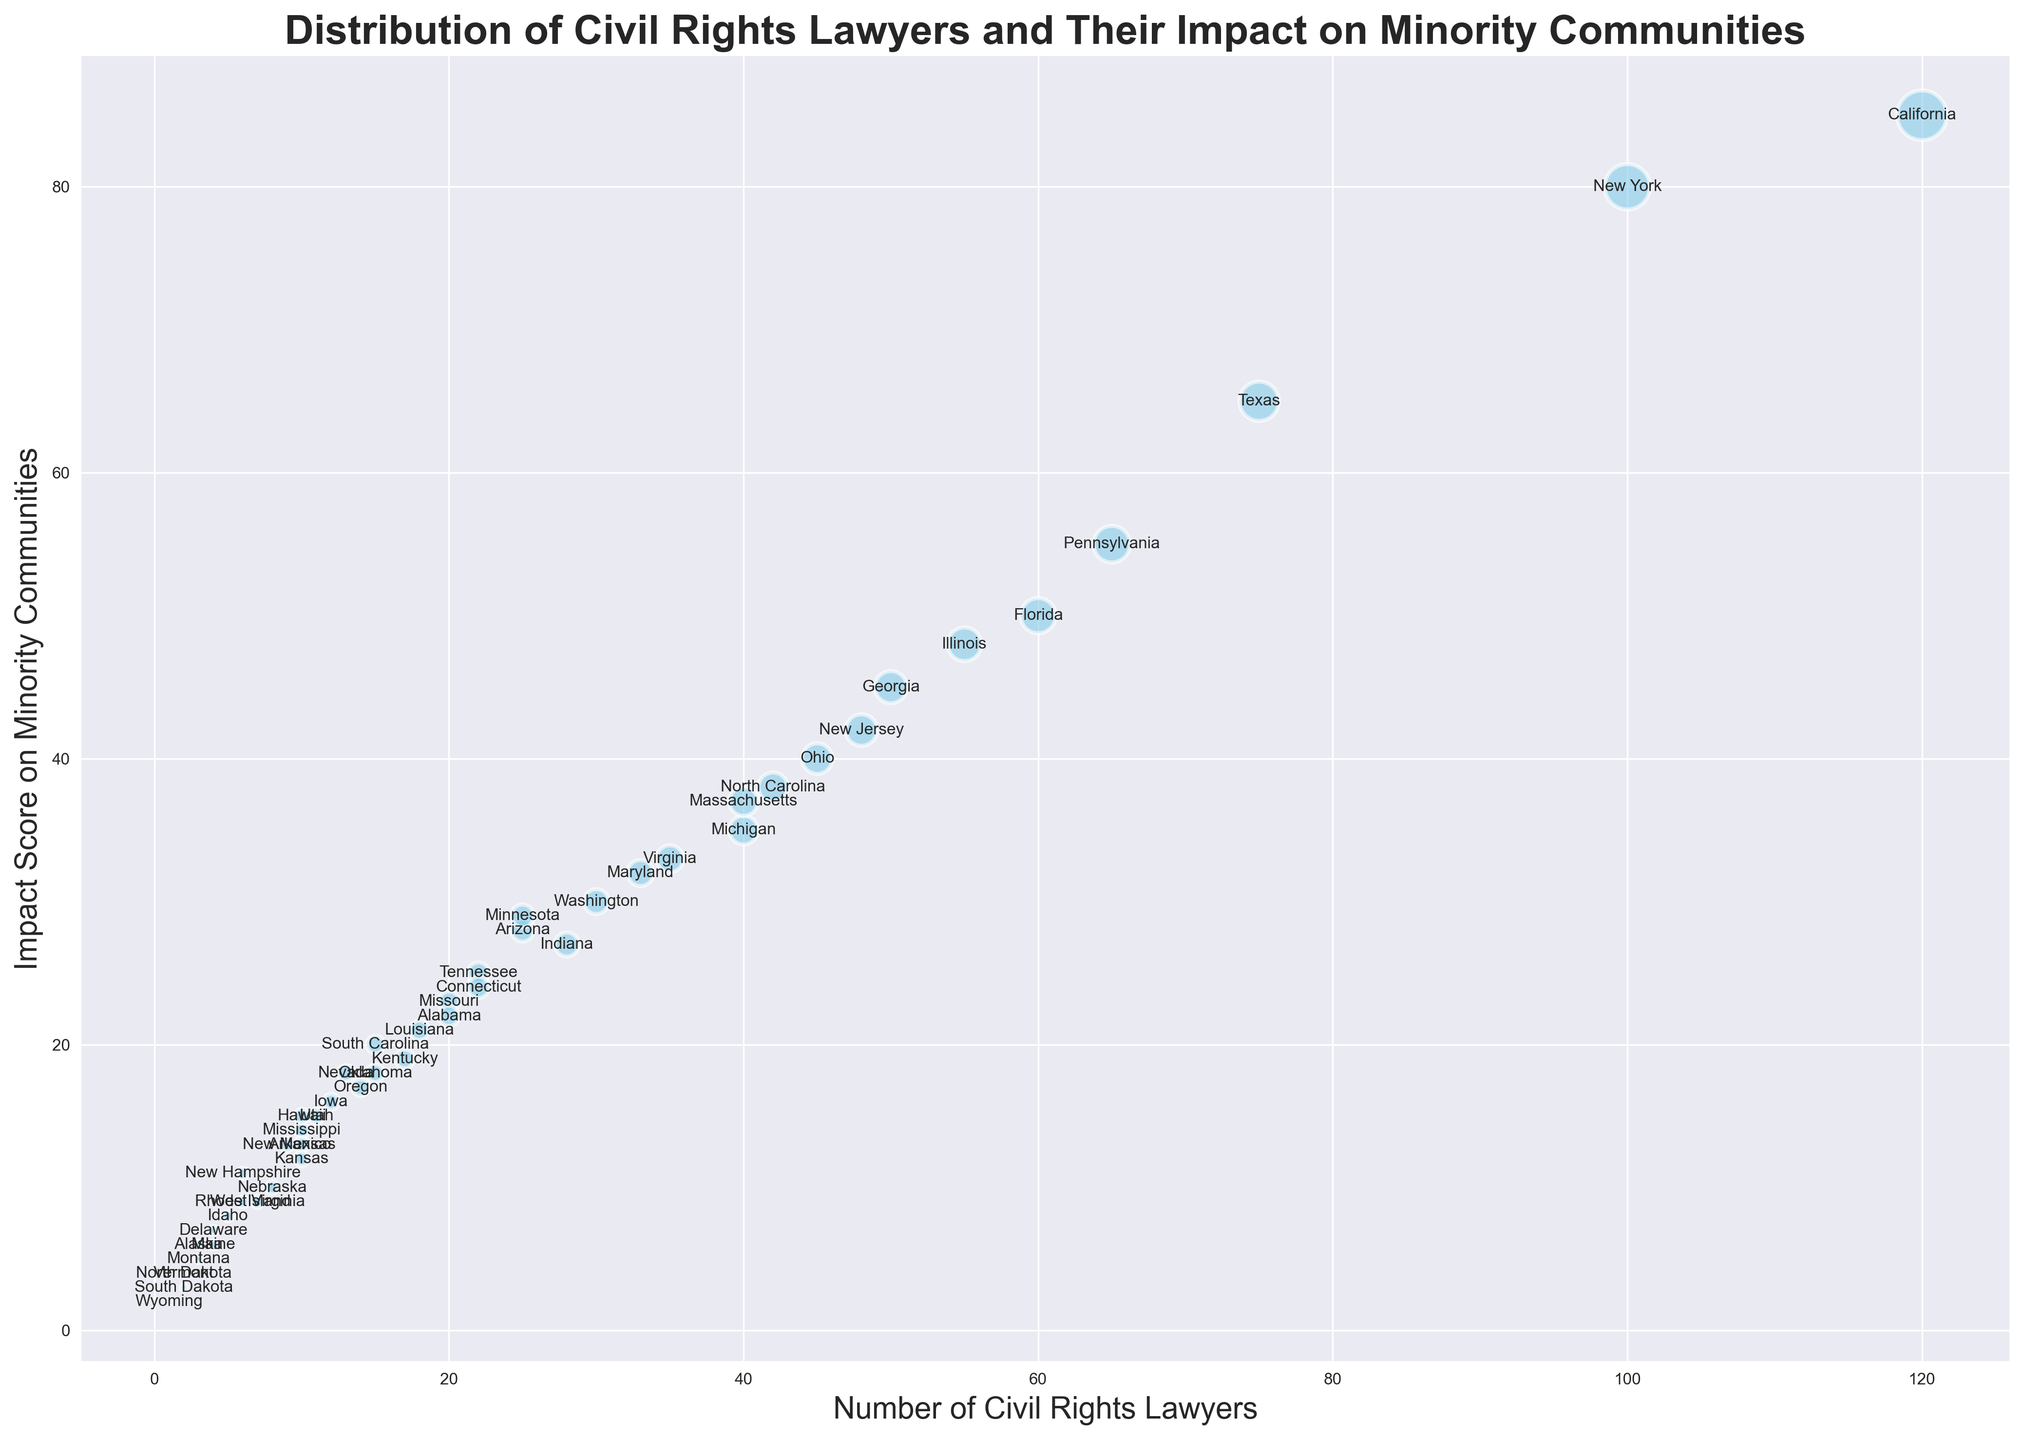What state has the highest number of civil rights lawyers? Identify the largest bubble on the x-axis, which corresponds to the state with the highest number of civil rights lawyers. The largest bubble is located at 120, which corresponds to California.
Answer: California Which state has the highest impact score on minority communities? Look for the bubble that is highest on the y-axis, indicating the highest impact score. The highest bubble on the y-axis corresponds to 85, which is California.
Answer: California How do the number of civil rights lawyers in Texas and Florida compare? Find the bubbles for Texas and Florida along the x-axis. Texas is at 75, and Florida is at 60. Thus, Texas has more civil rights lawyers than Florida.
Answer: Texas has more What is the combined number of civil rights lawyers in Ohio and New Jersey? Find and sum the number of civil rights lawyers for Ohio and New Jersey. Ohio has 45 lawyers, and New Jersey has 48. The combined number is 45 + 48.
Answer: 93 Which state has more civil rights lawyers, Georgia or Arizona? Identify the bubbles for Georgia and Arizona along the x-axis. Georgia is at 50, while Arizona is at 25. Georgia has more civil rights lawyers.
Answer: Georgia What is the impact score on minority communities for states with exactly 40 civil rights lawyers? Locate bubbles on the x-axis at 40 (Michigan and Massachusetts). Michigan has an impact score of 35, and Massachusetts has an impact score of 37.
Answer: 35 (Michigan), 37 (Massachusetts) Which state has the lowest impact score on minority communities? Identify the bubble lowest on the y-axis. The lowest impact score bubble is at 2, corresponding to Wyoming.
Answer: Wyoming How many states have an impact score above 50? Count the bubbles with y-values above 50. California, New York, Texas, and Pennsylvania are the states above 50. There are four states.
Answer: 4 Which state has the largest bubble size but a lower impact score than New York? Compare New York's impact score (80) to other large bubbles. California's bubble is the largest (120 lawyers) but has an impact score of 85, which is not lower. Texas has 75 lawyers but with an impact score of 65, which is lower.
Answer: Texas What's the difference in the number of civil rights lawyers between Virginia and Louisiana? Find the bubbles for Virginia and Louisiana along the x-axis. Virginia has 35 lawyers, and Louisiana has 18. The difference is 35 - 18.
Answer: 17 